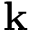Convert formula to latex. <formula><loc_0><loc_0><loc_500><loc_500>k</formula> 